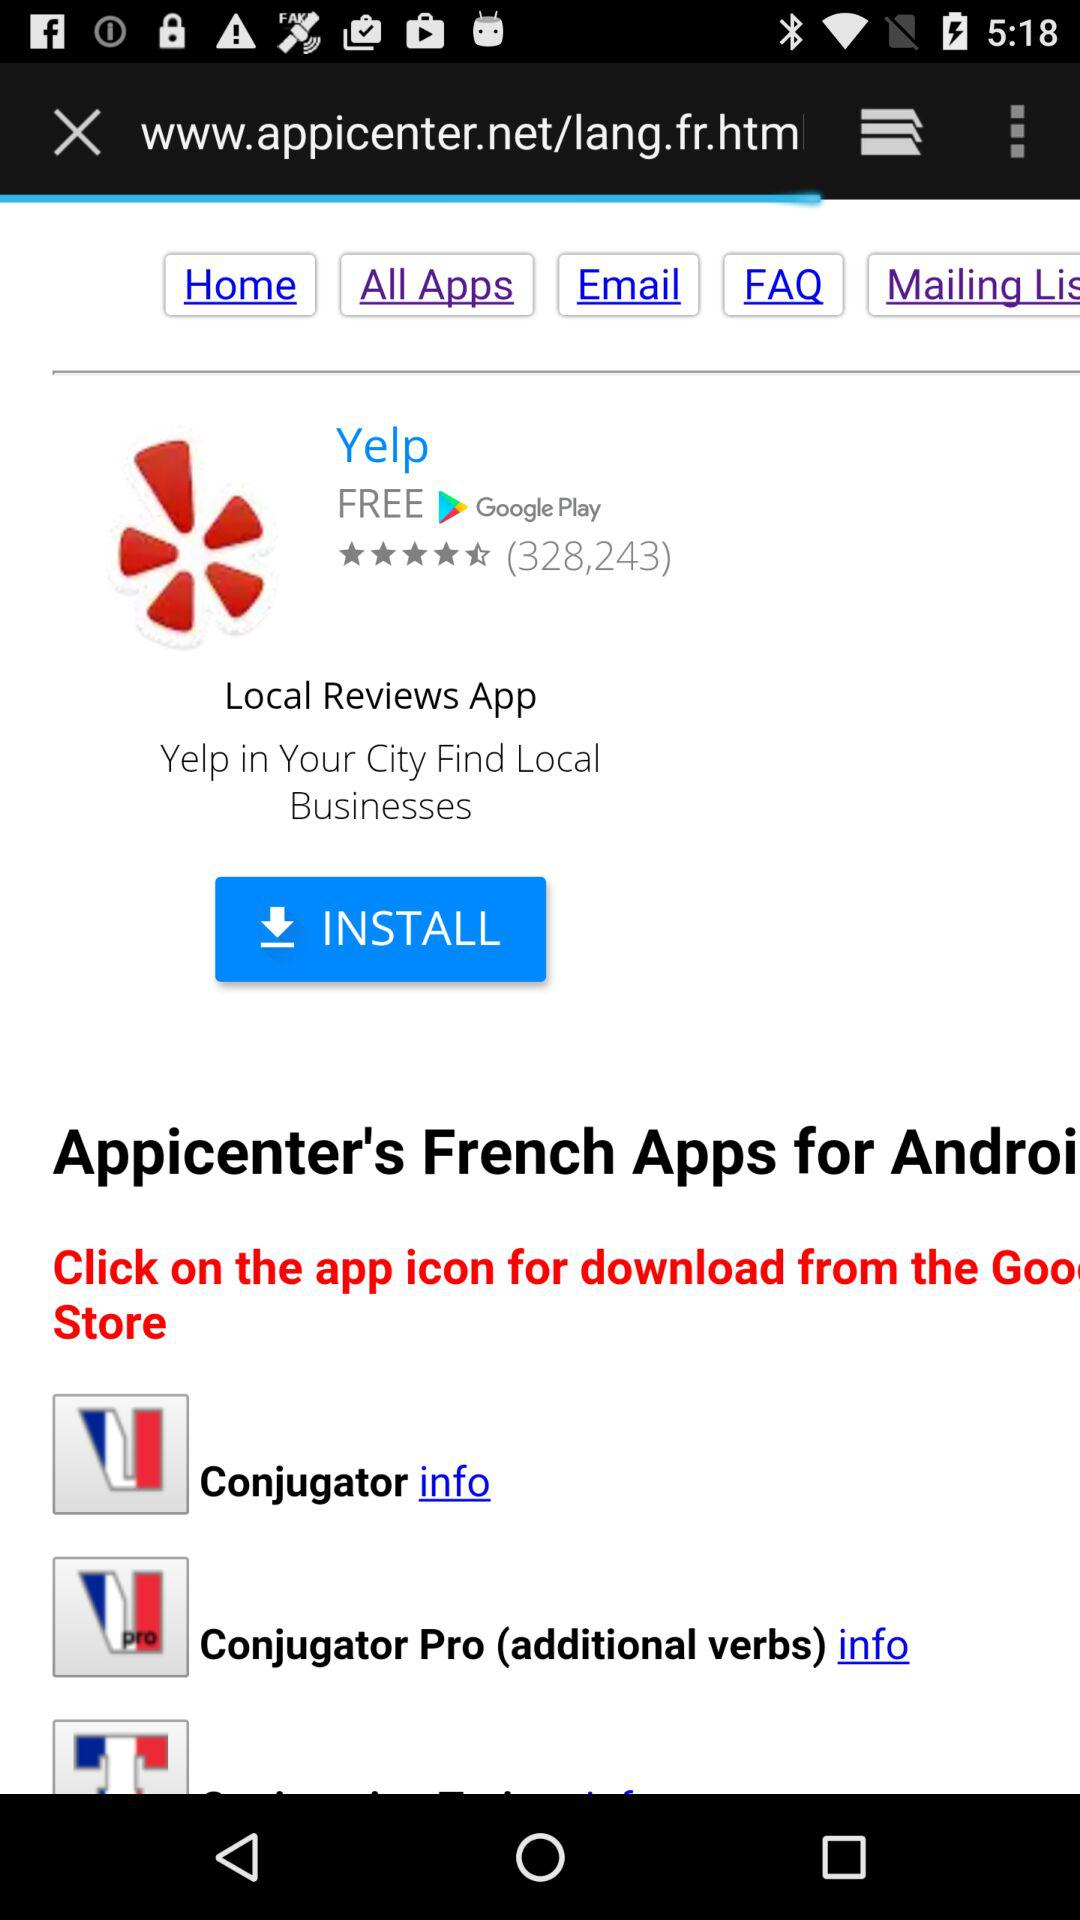What is the rating of the application? The rating of the application is 4.5 stars. 